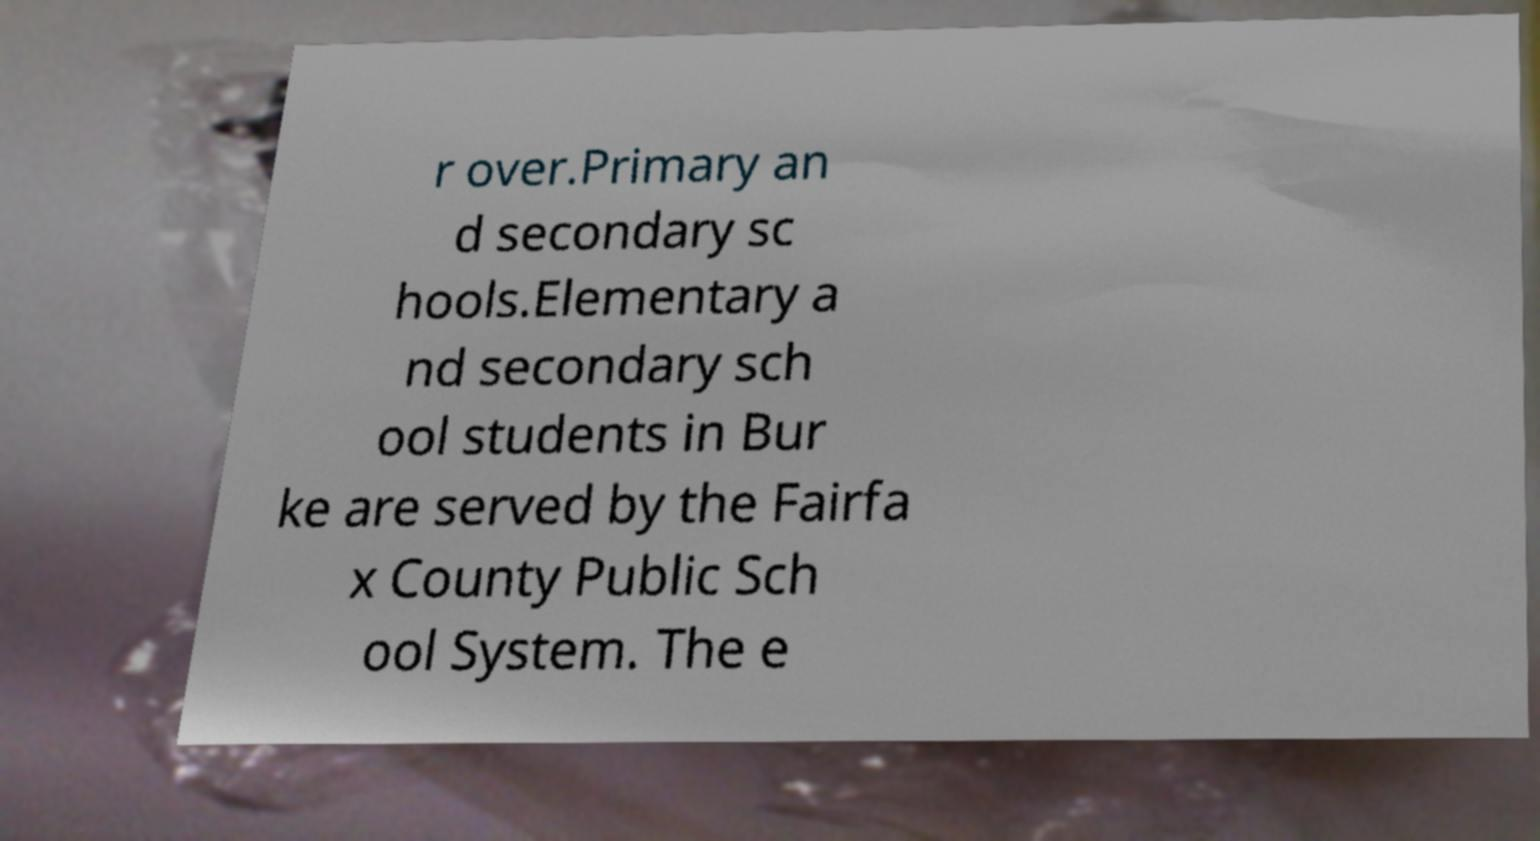Can you accurately transcribe the text from the provided image for me? r over.Primary an d secondary sc hools.Elementary a nd secondary sch ool students in Bur ke are served by the Fairfa x County Public Sch ool System. The e 